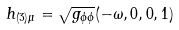<formula> <loc_0><loc_0><loc_500><loc_500>h _ { ( 3 ) \mu } = \sqrt { g _ { \phi \phi } } ( - \omega , 0 , 0 , 1 )</formula> 